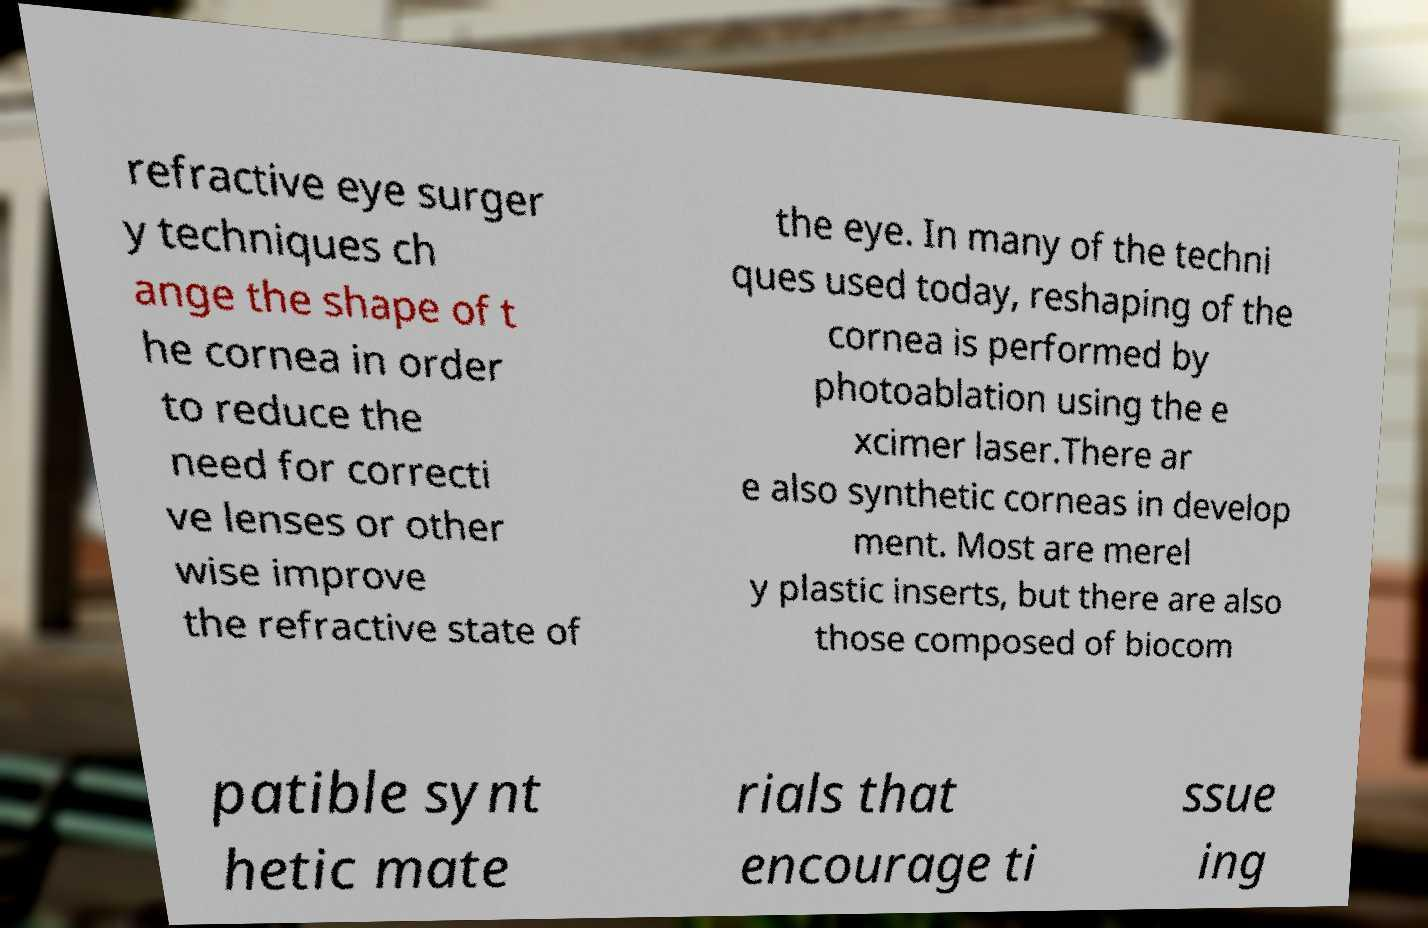Can you read and provide the text displayed in the image?This photo seems to have some interesting text. Can you extract and type it out for me? refractive eye surger y techniques ch ange the shape of t he cornea in order to reduce the need for correcti ve lenses or other wise improve the refractive state of the eye. In many of the techni ques used today, reshaping of the cornea is performed by photoablation using the e xcimer laser.There ar e also synthetic corneas in develop ment. Most are merel y plastic inserts, but there are also those composed of biocom patible synt hetic mate rials that encourage ti ssue ing 